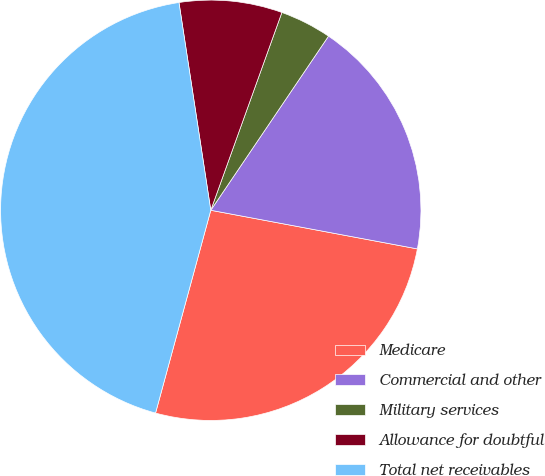Convert chart to OTSL. <chart><loc_0><loc_0><loc_500><loc_500><pie_chart><fcel>Medicare<fcel>Commercial and other<fcel>Military services<fcel>Allowance for doubtful<fcel>Total net receivables<nl><fcel>26.29%<fcel>18.48%<fcel>3.97%<fcel>7.91%<fcel>43.35%<nl></chart> 